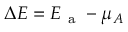<formula> <loc_0><loc_0><loc_500><loc_500>\Delta E = E _ { a } - \mu _ { A }</formula> 